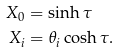<formula> <loc_0><loc_0><loc_500><loc_500>X _ { 0 } & = \sinh \tau \\ X _ { i } & = \theta _ { i } \cosh \tau .</formula> 